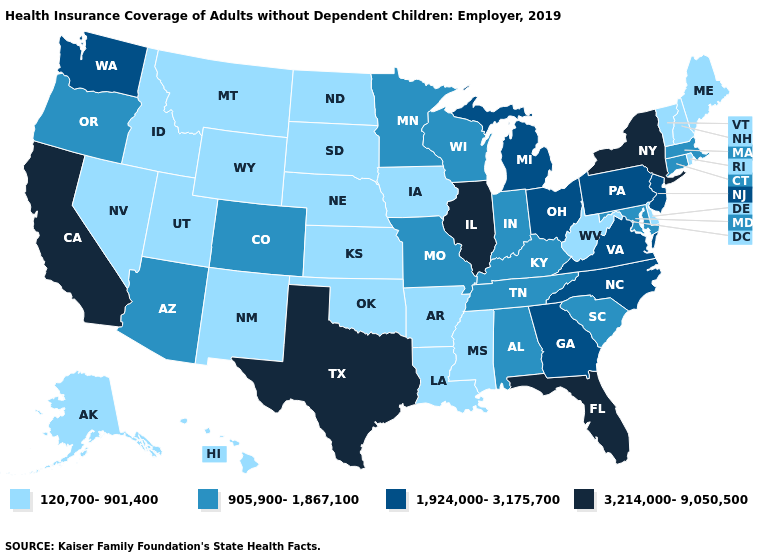What is the value of Florida?
Write a very short answer. 3,214,000-9,050,500. What is the highest value in the USA?
Keep it brief. 3,214,000-9,050,500. Is the legend a continuous bar?
Be succinct. No. Name the states that have a value in the range 120,700-901,400?
Short answer required. Alaska, Arkansas, Delaware, Hawaii, Idaho, Iowa, Kansas, Louisiana, Maine, Mississippi, Montana, Nebraska, Nevada, New Hampshire, New Mexico, North Dakota, Oklahoma, Rhode Island, South Dakota, Utah, Vermont, West Virginia, Wyoming. Name the states that have a value in the range 3,214,000-9,050,500?
Quick response, please. California, Florida, Illinois, New York, Texas. Which states have the lowest value in the Northeast?
Short answer required. Maine, New Hampshire, Rhode Island, Vermont. What is the value of Indiana?
Write a very short answer. 905,900-1,867,100. What is the value of Georgia?
Be succinct. 1,924,000-3,175,700. How many symbols are there in the legend?
Give a very brief answer. 4. What is the value of Oklahoma?
Keep it brief. 120,700-901,400. Does Oklahoma have the highest value in the USA?
Answer briefly. No. How many symbols are there in the legend?
Concise answer only. 4. Does South Dakota have the same value as Delaware?
Quick response, please. Yes. Does Louisiana have the same value as Wisconsin?
Give a very brief answer. No. Among the states that border Georgia , which have the highest value?
Concise answer only. Florida. 